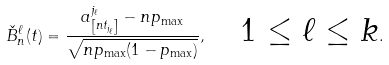<formula> <loc_0><loc_0><loc_500><loc_500>\check { B } ^ { \ell } _ { n } ( t ) = \frac { a ^ { j _ { \ell } } _ { \left [ n t _ { j _ { \ell } } \right ] } - n p _ { \max } } { \sqrt { n p _ { \max } ( 1 - p _ { \max } ) } } , \quad \text {$1 \leq \ell \leq k$} .</formula> 